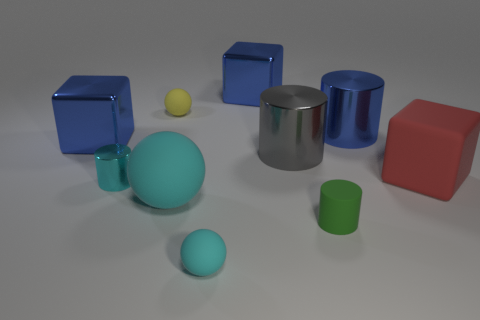Subtract all cyan spheres. How many were subtracted if there are1cyan spheres left? 1 Subtract all shiny cylinders. How many cylinders are left? 1 Subtract all blue cylinders. How many cyan spheres are left? 2 Subtract all yellow spheres. How many spheres are left? 2 Subtract all balls. How many objects are left? 7 Subtract 1 spheres. How many spheres are left? 2 Subtract all large cyan shiny spheres. Subtract all tiny green objects. How many objects are left? 9 Add 6 tiny green objects. How many tiny green objects are left? 7 Add 5 cyan metal cylinders. How many cyan metal cylinders exist? 6 Subtract 0 purple cubes. How many objects are left? 10 